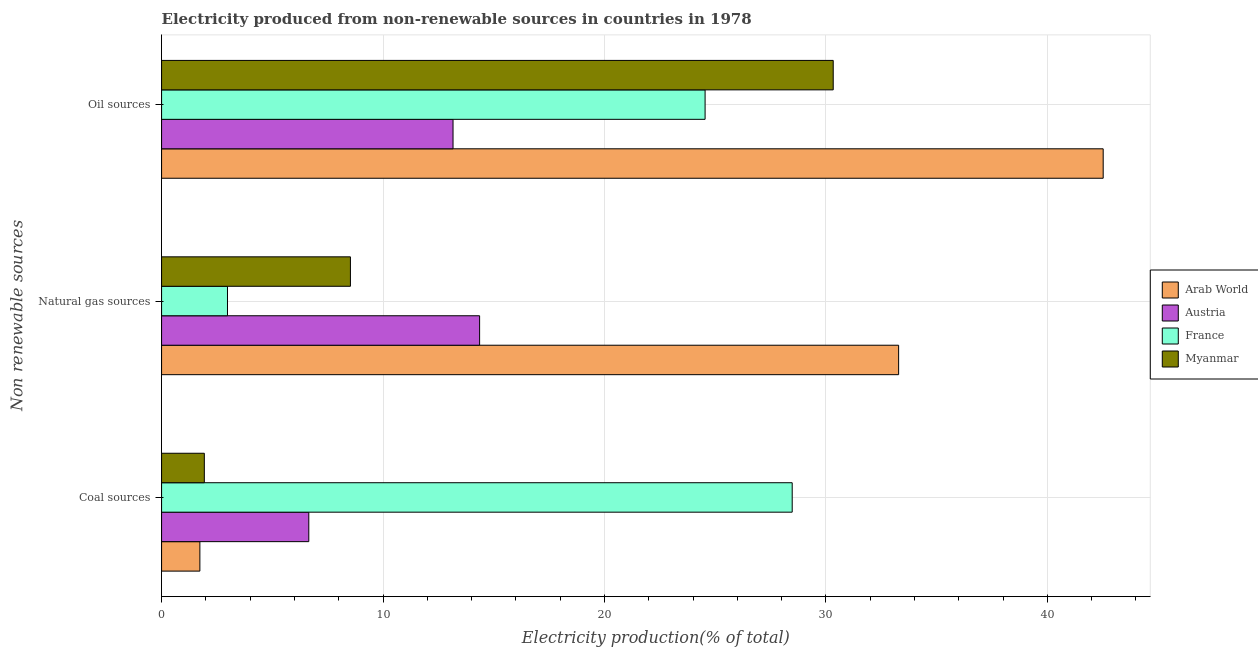How many groups of bars are there?
Ensure brevity in your answer.  3. Are the number of bars on each tick of the Y-axis equal?
Keep it short and to the point. Yes. How many bars are there on the 3rd tick from the bottom?
Give a very brief answer. 4. What is the label of the 1st group of bars from the top?
Your answer should be very brief. Oil sources. What is the percentage of electricity produced by oil sources in France?
Keep it short and to the point. 24.54. Across all countries, what is the maximum percentage of electricity produced by coal?
Provide a succinct answer. 28.48. Across all countries, what is the minimum percentage of electricity produced by oil sources?
Ensure brevity in your answer.  13.16. In which country was the percentage of electricity produced by oil sources maximum?
Ensure brevity in your answer.  Arab World. In which country was the percentage of electricity produced by coal minimum?
Offer a very short reply. Arab World. What is the total percentage of electricity produced by natural gas in the graph?
Make the answer very short. 59.15. What is the difference between the percentage of electricity produced by oil sources in Myanmar and that in France?
Give a very brief answer. 5.79. What is the difference between the percentage of electricity produced by coal in Myanmar and the percentage of electricity produced by natural gas in Austria?
Your answer should be very brief. -12.43. What is the average percentage of electricity produced by oil sources per country?
Provide a succinct answer. 27.64. What is the difference between the percentage of electricity produced by oil sources and percentage of electricity produced by natural gas in Arab World?
Keep it short and to the point. 9.24. What is the ratio of the percentage of electricity produced by coal in France to that in Austria?
Provide a succinct answer. 4.28. Is the difference between the percentage of electricity produced by natural gas in Arab World and France greater than the difference between the percentage of electricity produced by oil sources in Arab World and France?
Make the answer very short. Yes. What is the difference between the highest and the second highest percentage of electricity produced by oil sources?
Provide a short and direct response. 12.19. What is the difference between the highest and the lowest percentage of electricity produced by oil sources?
Your answer should be very brief. 29.36. Is the sum of the percentage of electricity produced by coal in Myanmar and France greater than the maximum percentage of electricity produced by natural gas across all countries?
Make the answer very short. No. What does the 4th bar from the top in Oil sources represents?
Keep it short and to the point. Arab World. What does the 4th bar from the bottom in Natural gas sources represents?
Keep it short and to the point. Myanmar. How many countries are there in the graph?
Ensure brevity in your answer.  4. Are the values on the major ticks of X-axis written in scientific E-notation?
Your answer should be compact. No. Does the graph contain any zero values?
Provide a succinct answer. No. How many legend labels are there?
Your answer should be very brief. 4. How are the legend labels stacked?
Offer a very short reply. Vertical. What is the title of the graph?
Offer a terse response. Electricity produced from non-renewable sources in countries in 1978. Does "Cambodia" appear as one of the legend labels in the graph?
Keep it short and to the point. No. What is the label or title of the X-axis?
Provide a succinct answer. Electricity production(% of total). What is the label or title of the Y-axis?
Provide a succinct answer. Non renewable sources. What is the Electricity production(% of total) of Arab World in Coal sources?
Your response must be concise. 1.73. What is the Electricity production(% of total) of Austria in Coal sources?
Your answer should be very brief. 6.65. What is the Electricity production(% of total) in France in Coal sources?
Your answer should be very brief. 28.48. What is the Electricity production(% of total) of Myanmar in Coal sources?
Give a very brief answer. 1.93. What is the Electricity production(% of total) in Arab World in Natural gas sources?
Ensure brevity in your answer.  33.28. What is the Electricity production(% of total) of Austria in Natural gas sources?
Your answer should be very brief. 14.36. What is the Electricity production(% of total) of France in Natural gas sources?
Provide a succinct answer. 2.98. What is the Electricity production(% of total) of Myanmar in Natural gas sources?
Your answer should be very brief. 8.53. What is the Electricity production(% of total) in Arab World in Oil sources?
Provide a succinct answer. 42.52. What is the Electricity production(% of total) in Austria in Oil sources?
Provide a short and direct response. 13.16. What is the Electricity production(% of total) of France in Oil sources?
Offer a very short reply. 24.54. What is the Electricity production(% of total) in Myanmar in Oil sources?
Make the answer very short. 30.33. Across all Non renewable sources, what is the maximum Electricity production(% of total) in Arab World?
Your answer should be compact. 42.52. Across all Non renewable sources, what is the maximum Electricity production(% of total) in Austria?
Make the answer very short. 14.36. Across all Non renewable sources, what is the maximum Electricity production(% of total) in France?
Give a very brief answer. 28.48. Across all Non renewable sources, what is the maximum Electricity production(% of total) of Myanmar?
Keep it short and to the point. 30.33. Across all Non renewable sources, what is the minimum Electricity production(% of total) of Arab World?
Give a very brief answer. 1.73. Across all Non renewable sources, what is the minimum Electricity production(% of total) of Austria?
Offer a terse response. 6.65. Across all Non renewable sources, what is the minimum Electricity production(% of total) in France?
Keep it short and to the point. 2.98. Across all Non renewable sources, what is the minimum Electricity production(% of total) of Myanmar?
Keep it short and to the point. 1.93. What is the total Electricity production(% of total) in Arab World in the graph?
Offer a very short reply. 77.53. What is the total Electricity production(% of total) in Austria in the graph?
Offer a terse response. 34.17. What is the total Electricity production(% of total) in France in the graph?
Provide a succinct answer. 56. What is the total Electricity production(% of total) in Myanmar in the graph?
Your response must be concise. 40.79. What is the difference between the Electricity production(% of total) of Arab World in Coal sources and that in Natural gas sources?
Ensure brevity in your answer.  -31.55. What is the difference between the Electricity production(% of total) of Austria in Coal sources and that in Natural gas sources?
Make the answer very short. -7.71. What is the difference between the Electricity production(% of total) of France in Coal sources and that in Natural gas sources?
Provide a short and direct response. 25.5. What is the difference between the Electricity production(% of total) of Myanmar in Coal sources and that in Natural gas sources?
Make the answer very short. -6.6. What is the difference between the Electricity production(% of total) in Arab World in Coal sources and that in Oil sources?
Your response must be concise. -40.79. What is the difference between the Electricity production(% of total) in Austria in Coal sources and that in Oil sources?
Your answer should be compact. -6.51. What is the difference between the Electricity production(% of total) of France in Coal sources and that in Oil sources?
Provide a short and direct response. 3.93. What is the difference between the Electricity production(% of total) of Myanmar in Coal sources and that in Oil sources?
Offer a terse response. -28.4. What is the difference between the Electricity production(% of total) in Arab World in Natural gas sources and that in Oil sources?
Your answer should be very brief. -9.24. What is the difference between the Electricity production(% of total) of Austria in Natural gas sources and that in Oil sources?
Provide a short and direct response. 1.2. What is the difference between the Electricity production(% of total) in France in Natural gas sources and that in Oil sources?
Provide a succinct answer. -21.57. What is the difference between the Electricity production(% of total) in Myanmar in Natural gas sources and that in Oil sources?
Offer a terse response. -21.8. What is the difference between the Electricity production(% of total) of Arab World in Coal sources and the Electricity production(% of total) of Austria in Natural gas sources?
Offer a terse response. -12.63. What is the difference between the Electricity production(% of total) of Arab World in Coal sources and the Electricity production(% of total) of France in Natural gas sources?
Your answer should be compact. -1.25. What is the difference between the Electricity production(% of total) of Arab World in Coal sources and the Electricity production(% of total) of Myanmar in Natural gas sources?
Your answer should be compact. -6.8. What is the difference between the Electricity production(% of total) of Austria in Coal sources and the Electricity production(% of total) of France in Natural gas sources?
Offer a very short reply. 3.67. What is the difference between the Electricity production(% of total) of Austria in Coal sources and the Electricity production(% of total) of Myanmar in Natural gas sources?
Give a very brief answer. -1.88. What is the difference between the Electricity production(% of total) of France in Coal sources and the Electricity production(% of total) of Myanmar in Natural gas sources?
Your response must be concise. 19.95. What is the difference between the Electricity production(% of total) of Arab World in Coal sources and the Electricity production(% of total) of Austria in Oil sources?
Your answer should be compact. -11.43. What is the difference between the Electricity production(% of total) of Arab World in Coal sources and the Electricity production(% of total) of France in Oil sources?
Offer a terse response. -22.82. What is the difference between the Electricity production(% of total) in Arab World in Coal sources and the Electricity production(% of total) in Myanmar in Oil sources?
Make the answer very short. -28.6. What is the difference between the Electricity production(% of total) in Austria in Coal sources and the Electricity production(% of total) in France in Oil sources?
Offer a very short reply. -17.9. What is the difference between the Electricity production(% of total) in Austria in Coal sources and the Electricity production(% of total) in Myanmar in Oil sources?
Your answer should be very brief. -23.68. What is the difference between the Electricity production(% of total) of France in Coal sources and the Electricity production(% of total) of Myanmar in Oil sources?
Provide a succinct answer. -1.85. What is the difference between the Electricity production(% of total) in Arab World in Natural gas sources and the Electricity production(% of total) in Austria in Oil sources?
Provide a succinct answer. 20.12. What is the difference between the Electricity production(% of total) of Arab World in Natural gas sources and the Electricity production(% of total) of France in Oil sources?
Offer a very short reply. 8.74. What is the difference between the Electricity production(% of total) in Arab World in Natural gas sources and the Electricity production(% of total) in Myanmar in Oil sources?
Make the answer very short. 2.95. What is the difference between the Electricity production(% of total) of Austria in Natural gas sources and the Electricity production(% of total) of France in Oil sources?
Make the answer very short. -10.18. What is the difference between the Electricity production(% of total) of Austria in Natural gas sources and the Electricity production(% of total) of Myanmar in Oil sources?
Provide a short and direct response. -15.97. What is the difference between the Electricity production(% of total) of France in Natural gas sources and the Electricity production(% of total) of Myanmar in Oil sources?
Ensure brevity in your answer.  -27.35. What is the average Electricity production(% of total) in Arab World per Non renewable sources?
Ensure brevity in your answer.  25.84. What is the average Electricity production(% of total) in Austria per Non renewable sources?
Provide a succinct answer. 11.39. What is the average Electricity production(% of total) of France per Non renewable sources?
Provide a succinct answer. 18.67. What is the average Electricity production(% of total) in Myanmar per Non renewable sources?
Keep it short and to the point. 13.6. What is the difference between the Electricity production(% of total) of Arab World and Electricity production(% of total) of Austria in Coal sources?
Your response must be concise. -4.92. What is the difference between the Electricity production(% of total) in Arab World and Electricity production(% of total) in France in Coal sources?
Provide a succinct answer. -26.75. What is the difference between the Electricity production(% of total) in Arab World and Electricity production(% of total) in Myanmar in Coal sources?
Keep it short and to the point. -0.2. What is the difference between the Electricity production(% of total) of Austria and Electricity production(% of total) of France in Coal sources?
Offer a very short reply. -21.83. What is the difference between the Electricity production(% of total) in Austria and Electricity production(% of total) in Myanmar in Coal sources?
Provide a short and direct response. 4.72. What is the difference between the Electricity production(% of total) of France and Electricity production(% of total) of Myanmar in Coal sources?
Give a very brief answer. 26.55. What is the difference between the Electricity production(% of total) of Arab World and Electricity production(% of total) of Austria in Natural gas sources?
Give a very brief answer. 18.92. What is the difference between the Electricity production(% of total) in Arab World and Electricity production(% of total) in France in Natural gas sources?
Offer a very short reply. 30.31. What is the difference between the Electricity production(% of total) in Arab World and Electricity production(% of total) in Myanmar in Natural gas sources?
Your response must be concise. 24.76. What is the difference between the Electricity production(% of total) in Austria and Electricity production(% of total) in France in Natural gas sources?
Offer a terse response. 11.39. What is the difference between the Electricity production(% of total) in Austria and Electricity production(% of total) in Myanmar in Natural gas sources?
Ensure brevity in your answer.  5.83. What is the difference between the Electricity production(% of total) of France and Electricity production(% of total) of Myanmar in Natural gas sources?
Your response must be concise. -5.55. What is the difference between the Electricity production(% of total) in Arab World and Electricity production(% of total) in Austria in Oil sources?
Offer a very short reply. 29.36. What is the difference between the Electricity production(% of total) of Arab World and Electricity production(% of total) of France in Oil sources?
Offer a terse response. 17.98. What is the difference between the Electricity production(% of total) in Arab World and Electricity production(% of total) in Myanmar in Oil sources?
Give a very brief answer. 12.19. What is the difference between the Electricity production(% of total) in Austria and Electricity production(% of total) in France in Oil sources?
Your answer should be compact. -11.38. What is the difference between the Electricity production(% of total) in Austria and Electricity production(% of total) in Myanmar in Oil sources?
Give a very brief answer. -17.17. What is the difference between the Electricity production(% of total) of France and Electricity production(% of total) of Myanmar in Oil sources?
Offer a terse response. -5.79. What is the ratio of the Electricity production(% of total) of Arab World in Coal sources to that in Natural gas sources?
Ensure brevity in your answer.  0.05. What is the ratio of the Electricity production(% of total) in Austria in Coal sources to that in Natural gas sources?
Ensure brevity in your answer.  0.46. What is the ratio of the Electricity production(% of total) in France in Coal sources to that in Natural gas sources?
Provide a short and direct response. 9.57. What is the ratio of the Electricity production(% of total) of Myanmar in Coal sources to that in Natural gas sources?
Give a very brief answer. 0.23. What is the ratio of the Electricity production(% of total) of Arab World in Coal sources to that in Oil sources?
Your answer should be very brief. 0.04. What is the ratio of the Electricity production(% of total) in Austria in Coal sources to that in Oil sources?
Make the answer very short. 0.51. What is the ratio of the Electricity production(% of total) of France in Coal sources to that in Oil sources?
Give a very brief answer. 1.16. What is the ratio of the Electricity production(% of total) in Myanmar in Coal sources to that in Oil sources?
Make the answer very short. 0.06. What is the ratio of the Electricity production(% of total) in Arab World in Natural gas sources to that in Oil sources?
Offer a very short reply. 0.78. What is the ratio of the Electricity production(% of total) of Austria in Natural gas sources to that in Oil sources?
Your answer should be very brief. 1.09. What is the ratio of the Electricity production(% of total) of France in Natural gas sources to that in Oil sources?
Provide a succinct answer. 0.12. What is the ratio of the Electricity production(% of total) in Myanmar in Natural gas sources to that in Oil sources?
Your answer should be very brief. 0.28. What is the difference between the highest and the second highest Electricity production(% of total) of Arab World?
Make the answer very short. 9.24. What is the difference between the highest and the second highest Electricity production(% of total) of Austria?
Your answer should be compact. 1.2. What is the difference between the highest and the second highest Electricity production(% of total) in France?
Your answer should be very brief. 3.93. What is the difference between the highest and the second highest Electricity production(% of total) of Myanmar?
Your answer should be compact. 21.8. What is the difference between the highest and the lowest Electricity production(% of total) in Arab World?
Make the answer very short. 40.79. What is the difference between the highest and the lowest Electricity production(% of total) of Austria?
Your response must be concise. 7.71. What is the difference between the highest and the lowest Electricity production(% of total) in France?
Your response must be concise. 25.5. What is the difference between the highest and the lowest Electricity production(% of total) of Myanmar?
Keep it short and to the point. 28.4. 